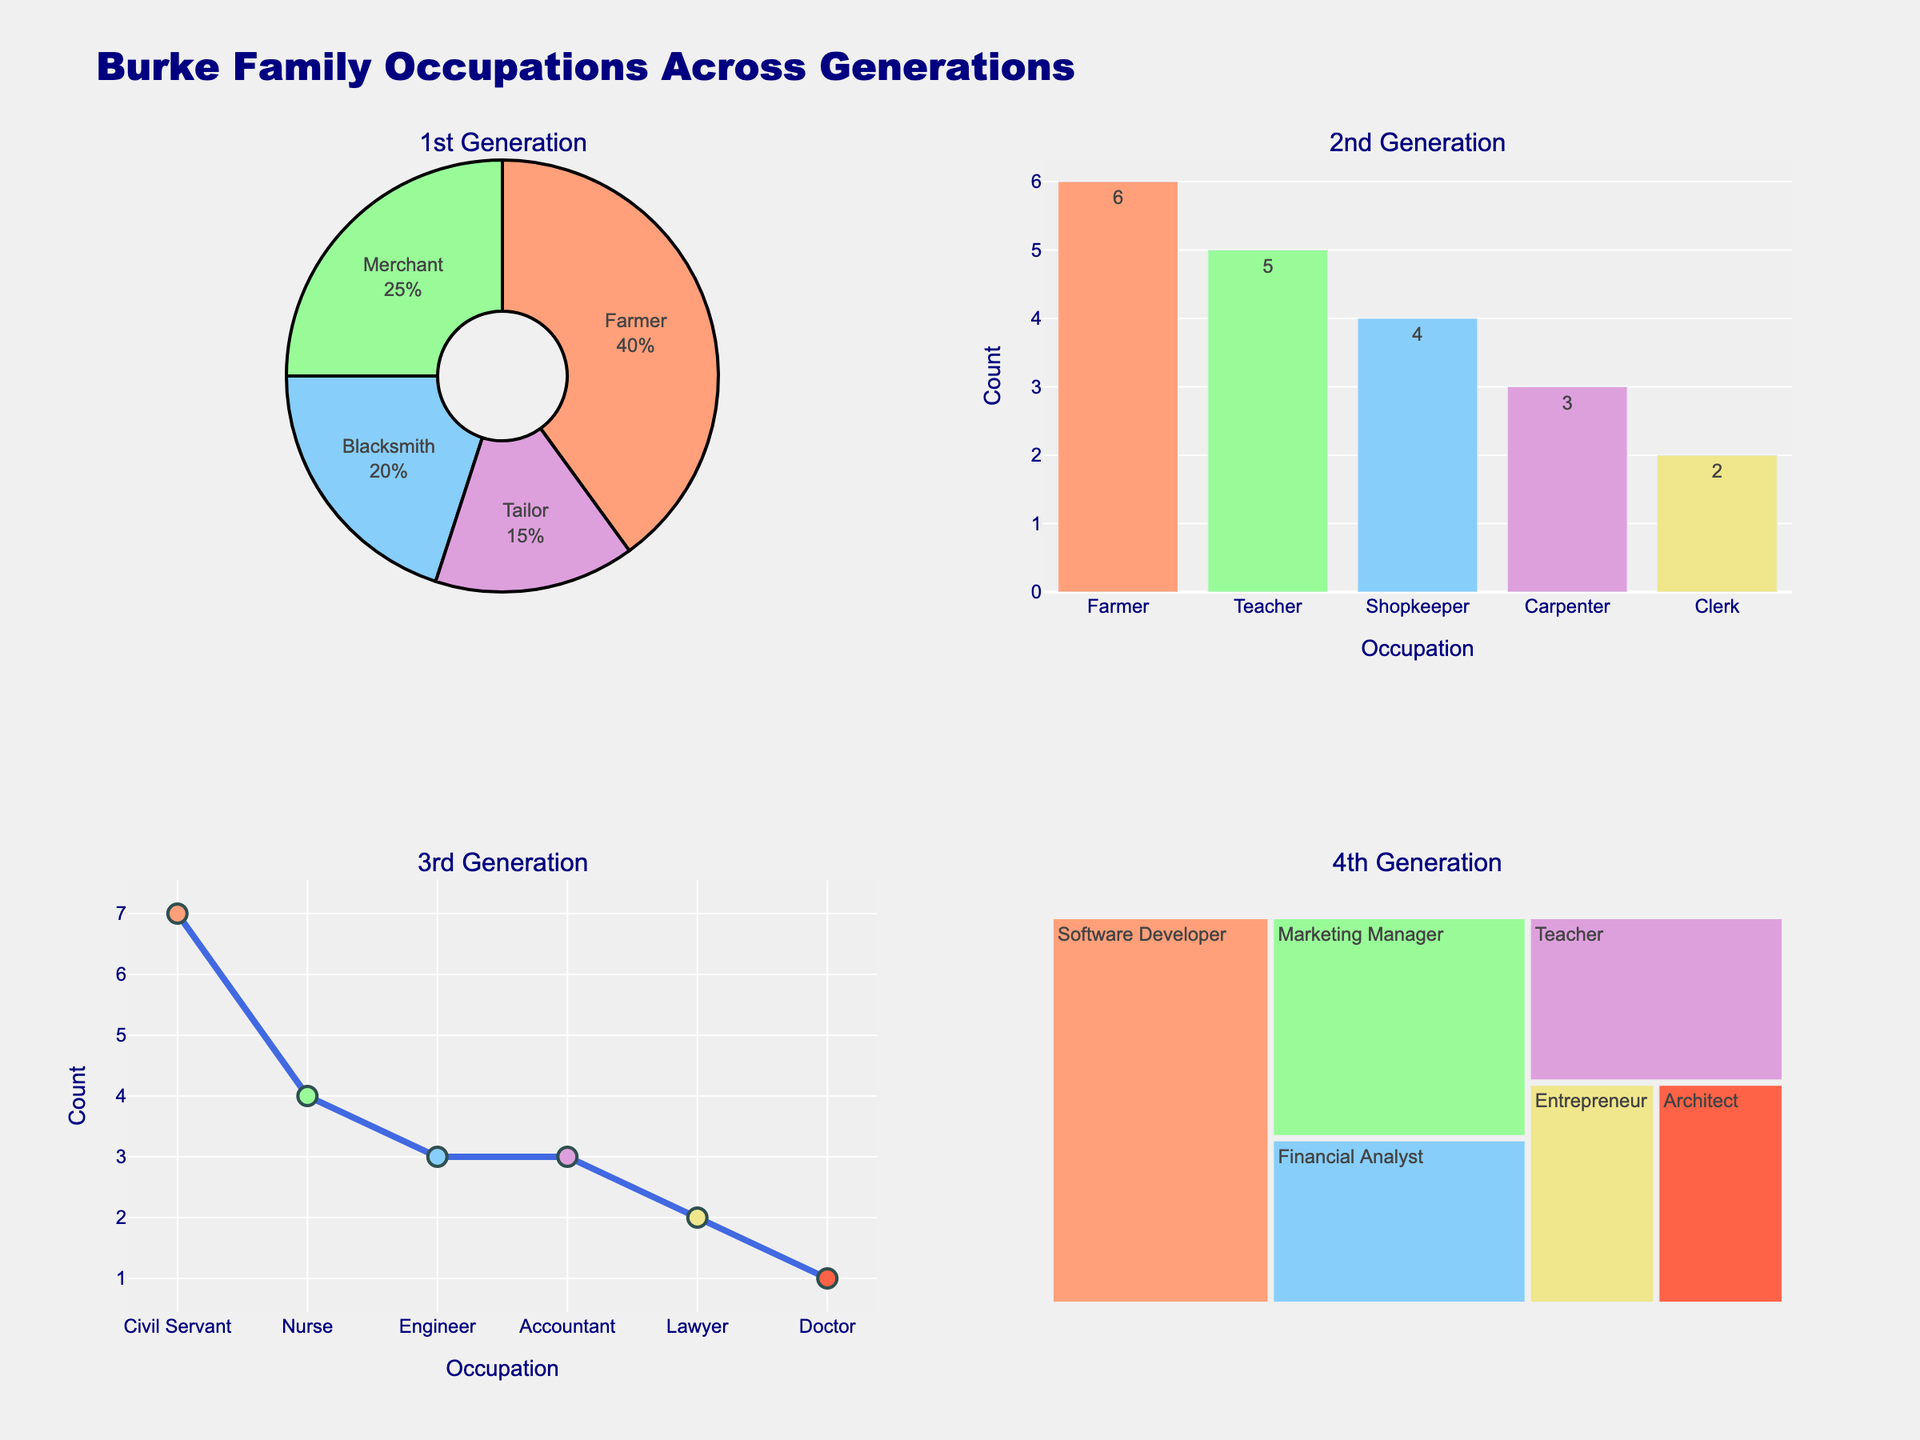What is the title of the figure? The title is written at the top of the figure, which usually gives a concise summary of what the figure represents. In this case, the title is "Adriaan Wildschutt's Race Performance Analysis."
Answer: Adriaan Wildschutt's Race Performance Analysis In which year did Adriaan Wildschutt see the biggest improvement in his 800m race time? Look at the '800m Progress' subplot and identify the year with the most significant drop in race time. From 2018 to 2019, the time dropped from 1:51.20 to 1:50.05, an improvement of 1.15 seconds.
Answer: 2019 How many data points are shown in the 'Time vs Distance (2020)' subplot? Count the number of markers in the scatter plot representing the different race distances in the year 2020. There are four races (800m, 1500m, 5000m, 10000m) represented.
Answer: 4 Which distance showed the largest improvement in time over the years displayed in the heatmap? Examine the colors and values in the 'Yearly Progress Across Distances' heatmap. The 5000m distance shows a substantial improvement from 13:58.34 in 2017 to 13:24.95 in 2020, a difference of about 33.39 seconds. Verify by comparing the color gradient changes across the years for each distance.
Answer: 5000m What is the color used for the bars in the 'Half Marathon Improvement' subplot? Look at the bars representing the half marathon times. The bars are colored in light green.
Answer: light green What is Adriaan Wildschutt's time for the 10000m race in 2020? Refer to the scatter plot in the 'Time vs Distance (2020)' subplot. The time for the 10000m race is shown as 27:55.30.
Answer: 27:55.30 Between which years did Adriaan Wildschutt see no improvement in his 800m race time? Check the '800m Progress' line chart for any years where the time did not change. From 2019 to 2020, the time marginally improved from 1:50.05 to 1:49.80, thus no year showed no improvement.
Answer: None How does the heatmap represent the yearly progress of Adriaan Wildschutt's race times? The heatmap uses color intensity (from light to dark) to represent the times across different distances and years. Darker colors indicate faster times.
Answer: Color intensity What was Adriaan Wildschutt's improvement time in the Half Marathon between 2019 and 2020? Look at the 'Half Marathon Improvement' bar chart and compare the 2019 and 2020 times. The 2019 time was 1:02:45 and the 2020 time was 1:01:30, a total improvement of 1 minute and 15 seconds.
Answer: 1:15 